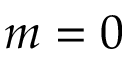Convert formula to latex. <formula><loc_0><loc_0><loc_500><loc_500>m = 0</formula> 